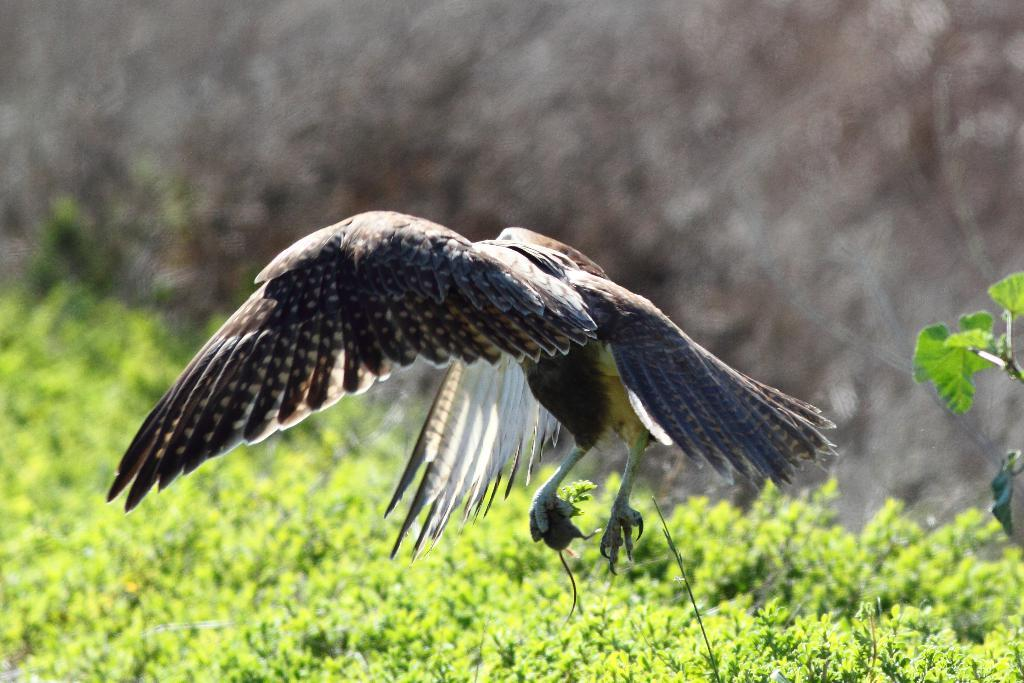What is the main subject in the foreground of the image? There is a bird in the foreground of the image. What is the bird doing with its claw? The bird is holding a rat with its claw. What is the position of the rat in the image? The rat is in the air, being held by the bird. What type of vegetation can be seen in the image? There is greenery in the bottom part of the image. What can be seen in the top part of the image? The sky is visible in the top part of the image. Can you describe the sky in the image? There is at least one cloud in the sky. What type of plantation can be seen in the image? There is no plantation present in the image. What process is the bird undergoing in the image? The bird is not undergoing any specific process; it is holding a rat with its claw. 